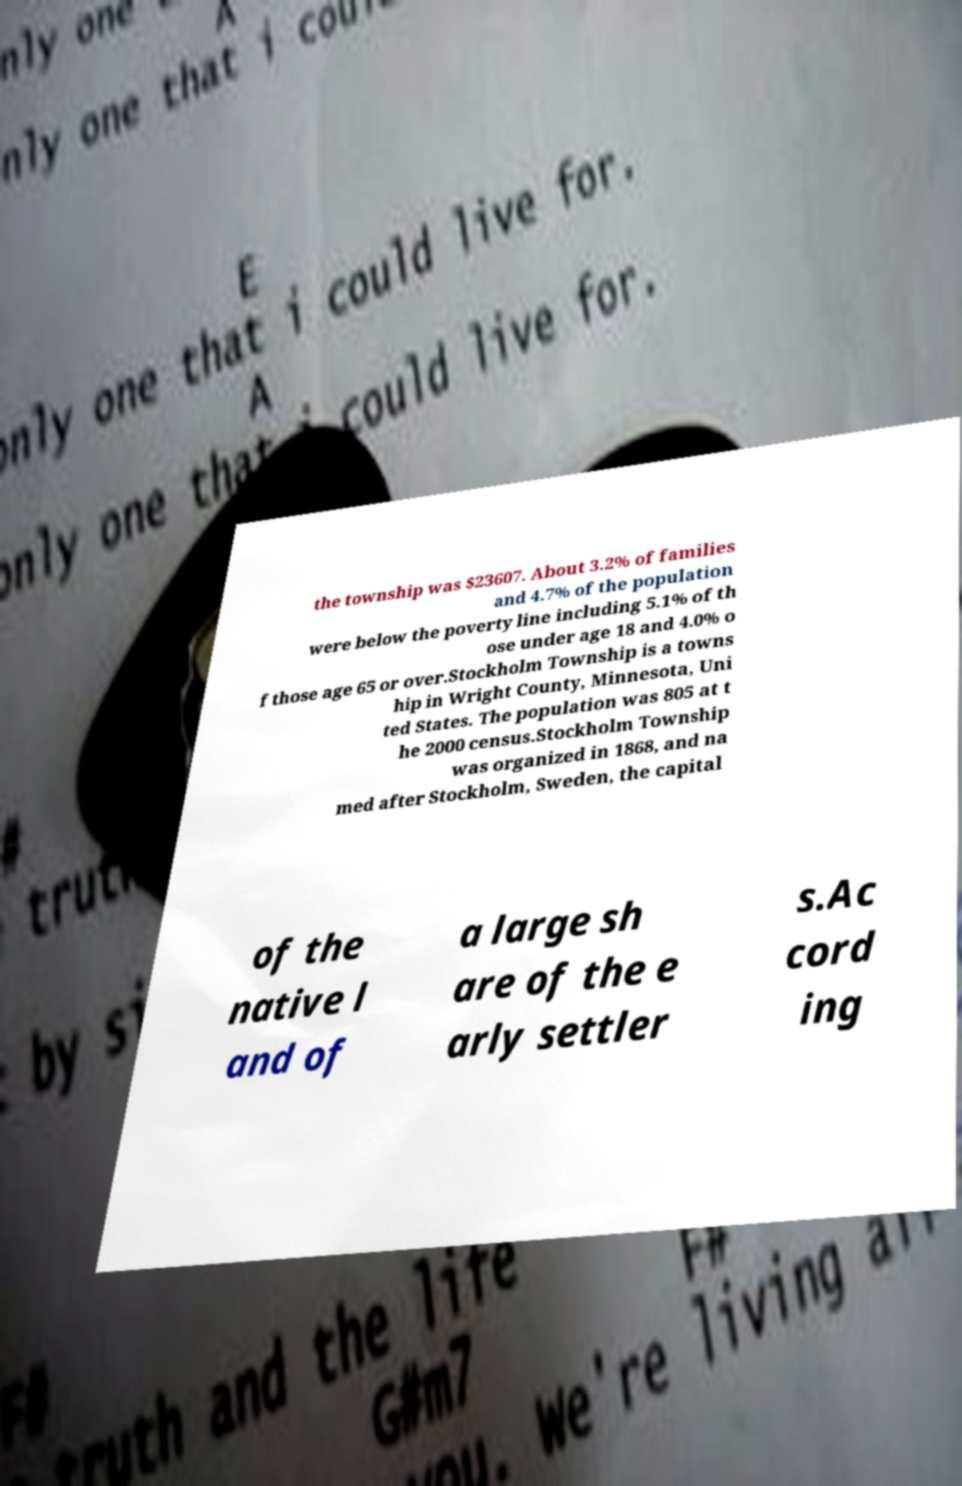Can you read and provide the text displayed in the image?This photo seems to have some interesting text. Can you extract and type it out for me? the township was $23607. About 3.2% of families and 4.7% of the population were below the poverty line including 5.1% of th ose under age 18 and 4.0% o f those age 65 or over.Stockholm Township is a towns hip in Wright County, Minnesota, Uni ted States. The population was 805 at t he 2000 census.Stockholm Township was organized in 1868, and na med after Stockholm, Sweden, the capital of the native l and of a large sh are of the e arly settler s.Ac cord ing 